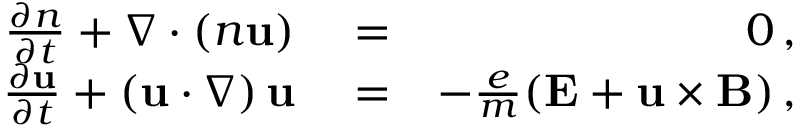Convert formula to latex. <formula><loc_0><loc_0><loc_500><loc_500>\begin{array} { r l r } { \frac { \partial n } { \partial t } + \nabla \cdot \left ( n { u } \right ) } & = } & { 0 \, , } \\ { \frac { \partial { u } } { \partial t } + \left ( { u } \cdot \nabla \right ) { u } } & = } & { - \frac { e } { m } ( { E } + { u } \times { B } ) \, , } \end{array}</formula> 